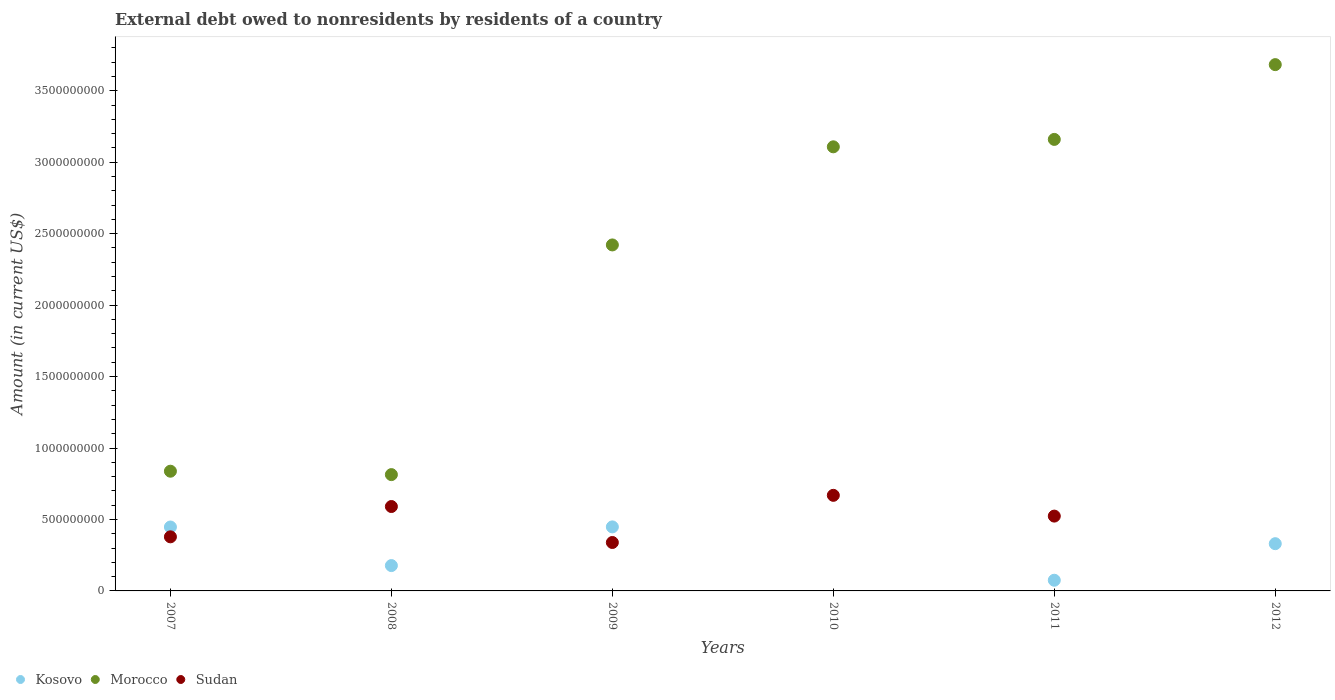Is the number of dotlines equal to the number of legend labels?
Keep it short and to the point. No. What is the external debt owed by residents in Kosovo in 2011?
Keep it short and to the point. 7.47e+07. Across all years, what is the maximum external debt owed by residents in Sudan?
Provide a succinct answer. 6.69e+08. Across all years, what is the minimum external debt owed by residents in Morocco?
Ensure brevity in your answer.  8.14e+08. In which year was the external debt owed by residents in Morocco maximum?
Provide a succinct answer. 2012. What is the total external debt owed by residents in Sudan in the graph?
Your response must be concise. 2.50e+09. What is the difference between the external debt owed by residents in Morocco in 2007 and that in 2009?
Give a very brief answer. -1.58e+09. What is the difference between the external debt owed by residents in Sudan in 2012 and the external debt owed by residents in Morocco in 2007?
Provide a short and direct response. -8.38e+08. What is the average external debt owed by residents in Morocco per year?
Ensure brevity in your answer.  2.34e+09. In the year 2012, what is the difference between the external debt owed by residents in Morocco and external debt owed by residents in Kosovo?
Your response must be concise. 3.35e+09. What is the ratio of the external debt owed by residents in Kosovo in 2009 to that in 2012?
Offer a very short reply. 1.36. What is the difference between the highest and the second highest external debt owed by residents in Sudan?
Give a very brief answer. 7.83e+07. What is the difference between the highest and the lowest external debt owed by residents in Morocco?
Make the answer very short. 2.87e+09. In how many years, is the external debt owed by residents in Morocco greater than the average external debt owed by residents in Morocco taken over all years?
Ensure brevity in your answer.  4. Is the external debt owed by residents in Kosovo strictly less than the external debt owed by residents in Morocco over the years?
Provide a short and direct response. Yes. How many years are there in the graph?
Provide a short and direct response. 6. Are the values on the major ticks of Y-axis written in scientific E-notation?
Offer a terse response. No. Where does the legend appear in the graph?
Your answer should be compact. Bottom left. What is the title of the graph?
Give a very brief answer. External debt owed to nonresidents by residents of a country. What is the label or title of the X-axis?
Keep it short and to the point. Years. What is the Amount (in current US$) in Kosovo in 2007?
Make the answer very short. 4.47e+08. What is the Amount (in current US$) in Morocco in 2007?
Your answer should be compact. 8.38e+08. What is the Amount (in current US$) in Sudan in 2007?
Your answer should be very brief. 3.79e+08. What is the Amount (in current US$) of Kosovo in 2008?
Your answer should be compact. 1.77e+08. What is the Amount (in current US$) in Morocco in 2008?
Provide a succinct answer. 8.14e+08. What is the Amount (in current US$) of Sudan in 2008?
Your answer should be compact. 5.91e+08. What is the Amount (in current US$) in Kosovo in 2009?
Make the answer very short. 4.48e+08. What is the Amount (in current US$) in Morocco in 2009?
Give a very brief answer. 2.42e+09. What is the Amount (in current US$) in Sudan in 2009?
Offer a very short reply. 3.39e+08. What is the Amount (in current US$) of Kosovo in 2010?
Your response must be concise. 0. What is the Amount (in current US$) in Morocco in 2010?
Make the answer very short. 3.11e+09. What is the Amount (in current US$) in Sudan in 2010?
Provide a succinct answer. 6.69e+08. What is the Amount (in current US$) in Kosovo in 2011?
Ensure brevity in your answer.  7.47e+07. What is the Amount (in current US$) in Morocco in 2011?
Provide a succinct answer. 3.16e+09. What is the Amount (in current US$) in Sudan in 2011?
Your response must be concise. 5.24e+08. What is the Amount (in current US$) of Kosovo in 2012?
Keep it short and to the point. 3.31e+08. What is the Amount (in current US$) of Morocco in 2012?
Your response must be concise. 3.68e+09. What is the Amount (in current US$) of Sudan in 2012?
Offer a terse response. 0. Across all years, what is the maximum Amount (in current US$) in Kosovo?
Offer a very short reply. 4.48e+08. Across all years, what is the maximum Amount (in current US$) in Morocco?
Offer a terse response. 3.68e+09. Across all years, what is the maximum Amount (in current US$) of Sudan?
Offer a very short reply. 6.69e+08. Across all years, what is the minimum Amount (in current US$) in Kosovo?
Ensure brevity in your answer.  0. Across all years, what is the minimum Amount (in current US$) of Morocco?
Your answer should be very brief. 8.14e+08. What is the total Amount (in current US$) of Kosovo in the graph?
Ensure brevity in your answer.  1.48e+09. What is the total Amount (in current US$) of Morocco in the graph?
Ensure brevity in your answer.  1.40e+1. What is the total Amount (in current US$) in Sudan in the graph?
Give a very brief answer. 2.50e+09. What is the difference between the Amount (in current US$) of Kosovo in 2007 and that in 2008?
Make the answer very short. 2.70e+08. What is the difference between the Amount (in current US$) of Morocco in 2007 and that in 2008?
Provide a succinct answer. 2.39e+07. What is the difference between the Amount (in current US$) in Sudan in 2007 and that in 2008?
Offer a terse response. -2.12e+08. What is the difference between the Amount (in current US$) of Kosovo in 2007 and that in 2009?
Make the answer very short. -8.17e+05. What is the difference between the Amount (in current US$) in Morocco in 2007 and that in 2009?
Provide a succinct answer. -1.58e+09. What is the difference between the Amount (in current US$) in Sudan in 2007 and that in 2009?
Give a very brief answer. 3.96e+07. What is the difference between the Amount (in current US$) in Morocco in 2007 and that in 2010?
Ensure brevity in your answer.  -2.27e+09. What is the difference between the Amount (in current US$) in Sudan in 2007 and that in 2010?
Your answer should be compact. -2.90e+08. What is the difference between the Amount (in current US$) in Kosovo in 2007 and that in 2011?
Offer a terse response. 3.73e+08. What is the difference between the Amount (in current US$) of Morocco in 2007 and that in 2011?
Give a very brief answer. -2.32e+09. What is the difference between the Amount (in current US$) of Sudan in 2007 and that in 2011?
Provide a short and direct response. -1.45e+08. What is the difference between the Amount (in current US$) in Kosovo in 2007 and that in 2012?
Your answer should be compact. 1.17e+08. What is the difference between the Amount (in current US$) of Morocco in 2007 and that in 2012?
Offer a terse response. -2.85e+09. What is the difference between the Amount (in current US$) in Kosovo in 2008 and that in 2009?
Provide a succinct answer. -2.71e+08. What is the difference between the Amount (in current US$) in Morocco in 2008 and that in 2009?
Keep it short and to the point. -1.61e+09. What is the difference between the Amount (in current US$) of Sudan in 2008 and that in 2009?
Keep it short and to the point. 2.52e+08. What is the difference between the Amount (in current US$) in Morocco in 2008 and that in 2010?
Provide a succinct answer. -2.29e+09. What is the difference between the Amount (in current US$) of Sudan in 2008 and that in 2010?
Your answer should be compact. -7.83e+07. What is the difference between the Amount (in current US$) of Kosovo in 2008 and that in 2011?
Keep it short and to the point. 1.03e+08. What is the difference between the Amount (in current US$) in Morocco in 2008 and that in 2011?
Make the answer very short. -2.35e+09. What is the difference between the Amount (in current US$) of Sudan in 2008 and that in 2011?
Your answer should be very brief. 6.70e+07. What is the difference between the Amount (in current US$) in Kosovo in 2008 and that in 2012?
Ensure brevity in your answer.  -1.53e+08. What is the difference between the Amount (in current US$) of Morocco in 2008 and that in 2012?
Ensure brevity in your answer.  -2.87e+09. What is the difference between the Amount (in current US$) in Morocco in 2009 and that in 2010?
Keep it short and to the point. -6.87e+08. What is the difference between the Amount (in current US$) of Sudan in 2009 and that in 2010?
Give a very brief answer. -3.30e+08. What is the difference between the Amount (in current US$) in Kosovo in 2009 and that in 2011?
Provide a succinct answer. 3.73e+08. What is the difference between the Amount (in current US$) of Morocco in 2009 and that in 2011?
Make the answer very short. -7.39e+08. What is the difference between the Amount (in current US$) in Sudan in 2009 and that in 2011?
Make the answer very short. -1.85e+08. What is the difference between the Amount (in current US$) in Kosovo in 2009 and that in 2012?
Ensure brevity in your answer.  1.18e+08. What is the difference between the Amount (in current US$) of Morocco in 2009 and that in 2012?
Ensure brevity in your answer.  -1.26e+09. What is the difference between the Amount (in current US$) of Morocco in 2010 and that in 2011?
Offer a terse response. -5.19e+07. What is the difference between the Amount (in current US$) in Sudan in 2010 and that in 2011?
Provide a succinct answer. 1.45e+08. What is the difference between the Amount (in current US$) of Morocco in 2010 and that in 2012?
Give a very brief answer. -5.75e+08. What is the difference between the Amount (in current US$) of Kosovo in 2011 and that in 2012?
Provide a succinct answer. -2.56e+08. What is the difference between the Amount (in current US$) in Morocco in 2011 and that in 2012?
Your answer should be compact. -5.23e+08. What is the difference between the Amount (in current US$) in Kosovo in 2007 and the Amount (in current US$) in Morocco in 2008?
Make the answer very short. -3.67e+08. What is the difference between the Amount (in current US$) of Kosovo in 2007 and the Amount (in current US$) of Sudan in 2008?
Make the answer very short. -1.43e+08. What is the difference between the Amount (in current US$) of Morocco in 2007 and the Amount (in current US$) of Sudan in 2008?
Give a very brief answer. 2.47e+08. What is the difference between the Amount (in current US$) in Kosovo in 2007 and the Amount (in current US$) in Morocco in 2009?
Offer a terse response. -1.97e+09. What is the difference between the Amount (in current US$) of Kosovo in 2007 and the Amount (in current US$) of Sudan in 2009?
Your answer should be compact. 1.08e+08. What is the difference between the Amount (in current US$) of Morocco in 2007 and the Amount (in current US$) of Sudan in 2009?
Offer a terse response. 4.99e+08. What is the difference between the Amount (in current US$) in Kosovo in 2007 and the Amount (in current US$) in Morocco in 2010?
Your response must be concise. -2.66e+09. What is the difference between the Amount (in current US$) of Kosovo in 2007 and the Amount (in current US$) of Sudan in 2010?
Provide a succinct answer. -2.22e+08. What is the difference between the Amount (in current US$) of Morocco in 2007 and the Amount (in current US$) of Sudan in 2010?
Your answer should be compact. 1.69e+08. What is the difference between the Amount (in current US$) of Kosovo in 2007 and the Amount (in current US$) of Morocco in 2011?
Make the answer very short. -2.71e+09. What is the difference between the Amount (in current US$) in Kosovo in 2007 and the Amount (in current US$) in Sudan in 2011?
Provide a short and direct response. -7.64e+07. What is the difference between the Amount (in current US$) in Morocco in 2007 and the Amount (in current US$) in Sudan in 2011?
Your answer should be very brief. 3.14e+08. What is the difference between the Amount (in current US$) in Kosovo in 2007 and the Amount (in current US$) in Morocco in 2012?
Provide a succinct answer. -3.24e+09. What is the difference between the Amount (in current US$) of Kosovo in 2008 and the Amount (in current US$) of Morocco in 2009?
Offer a very short reply. -2.24e+09. What is the difference between the Amount (in current US$) of Kosovo in 2008 and the Amount (in current US$) of Sudan in 2009?
Offer a terse response. -1.62e+08. What is the difference between the Amount (in current US$) in Morocco in 2008 and the Amount (in current US$) in Sudan in 2009?
Offer a very short reply. 4.75e+08. What is the difference between the Amount (in current US$) of Kosovo in 2008 and the Amount (in current US$) of Morocco in 2010?
Make the answer very short. -2.93e+09. What is the difference between the Amount (in current US$) of Kosovo in 2008 and the Amount (in current US$) of Sudan in 2010?
Provide a succinct answer. -4.92e+08. What is the difference between the Amount (in current US$) of Morocco in 2008 and the Amount (in current US$) of Sudan in 2010?
Your response must be concise. 1.45e+08. What is the difference between the Amount (in current US$) of Kosovo in 2008 and the Amount (in current US$) of Morocco in 2011?
Make the answer very short. -2.98e+09. What is the difference between the Amount (in current US$) in Kosovo in 2008 and the Amount (in current US$) in Sudan in 2011?
Offer a very short reply. -3.46e+08. What is the difference between the Amount (in current US$) of Morocco in 2008 and the Amount (in current US$) of Sudan in 2011?
Give a very brief answer. 2.90e+08. What is the difference between the Amount (in current US$) of Kosovo in 2008 and the Amount (in current US$) of Morocco in 2012?
Provide a succinct answer. -3.51e+09. What is the difference between the Amount (in current US$) of Kosovo in 2009 and the Amount (in current US$) of Morocco in 2010?
Your answer should be compact. -2.66e+09. What is the difference between the Amount (in current US$) of Kosovo in 2009 and the Amount (in current US$) of Sudan in 2010?
Give a very brief answer. -2.21e+08. What is the difference between the Amount (in current US$) in Morocco in 2009 and the Amount (in current US$) in Sudan in 2010?
Your answer should be compact. 1.75e+09. What is the difference between the Amount (in current US$) of Kosovo in 2009 and the Amount (in current US$) of Morocco in 2011?
Your answer should be compact. -2.71e+09. What is the difference between the Amount (in current US$) in Kosovo in 2009 and the Amount (in current US$) in Sudan in 2011?
Your response must be concise. -7.55e+07. What is the difference between the Amount (in current US$) of Morocco in 2009 and the Amount (in current US$) of Sudan in 2011?
Ensure brevity in your answer.  1.90e+09. What is the difference between the Amount (in current US$) of Kosovo in 2009 and the Amount (in current US$) of Morocco in 2012?
Provide a succinct answer. -3.23e+09. What is the difference between the Amount (in current US$) of Morocco in 2010 and the Amount (in current US$) of Sudan in 2011?
Offer a very short reply. 2.58e+09. What is the difference between the Amount (in current US$) of Kosovo in 2011 and the Amount (in current US$) of Morocco in 2012?
Provide a succinct answer. -3.61e+09. What is the average Amount (in current US$) in Kosovo per year?
Make the answer very short. 2.46e+08. What is the average Amount (in current US$) of Morocco per year?
Offer a terse response. 2.34e+09. What is the average Amount (in current US$) in Sudan per year?
Your answer should be compact. 4.17e+08. In the year 2007, what is the difference between the Amount (in current US$) in Kosovo and Amount (in current US$) in Morocco?
Provide a succinct answer. -3.91e+08. In the year 2007, what is the difference between the Amount (in current US$) in Kosovo and Amount (in current US$) in Sudan?
Give a very brief answer. 6.87e+07. In the year 2007, what is the difference between the Amount (in current US$) in Morocco and Amount (in current US$) in Sudan?
Your answer should be very brief. 4.59e+08. In the year 2008, what is the difference between the Amount (in current US$) of Kosovo and Amount (in current US$) of Morocco?
Your answer should be very brief. -6.37e+08. In the year 2008, what is the difference between the Amount (in current US$) of Kosovo and Amount (in current US$) of Sudan?
Provide a short and direct response. -4.13e+08. In the year 2008, what is the difference between the Amount (in current US$) of Morocco and Amount (in current US$) of Sudan?
Keep it short and to the point. 2.23e+08. In the year 2009, what is the difference between the Amount (in current US$) of Kosovo and Amount (in current US$) of Morocco?
Ensure brevity in your answer.  -1.97e+09. In the year 2009, what is the difference between the Amount (in current US$) in Kosovo and Amount (in current US$) in Sudan?
Ensure brevity in your answer.  1.09e+08. In the year 2009, what is the difference between the Amount (in current US$) in Morocco and Amount (in current US$) in Sudan?
Your answer should be very brief. 2.08e+09. In the year 2010, what is the difference between the Amount (in current US$) in Morocco and Amount (in current US$) in Sudan?
Offer a very short reply. 2.44e+09. In the year 2011, what is the difference between the Amount (in current US$) of Kosovo and Amount (in current US$) of Morocco?
Keep it short and to the point. -3.09e+09. In the year 2011, what is the difference between the Amount (in current US$) of Kosovo and Amount (in current US$) of Sudan?
Give a very brief answer. -4.49e+08. In the year 2011, what is the difference between the Amount (in current US$) in Morocco and Amount (in current US$) in Sudan?
Your response must be concise. 2.64e+09. In the year 2012, what is the difference between the Amount (in current US$) of Kosovo and Amount (in current US$) of Morocco?
Ensure brevity in your answer.  -3.35e+09. What is the ratio of the Amount (in current US$) of Kosovo in 2007 to that in 2008?
Provide a succinct answer. 2.52. What is the ratio of the Amount (in current US$) in Morocco in 2007 to that in 2008?
Your response must be concise. 1.03. What is the ratio of the Amount (in current US$) in Sudan in 2007 to that in 2008?
Keep it short and to the point. 0.64. What is the ratio of the Amount (in current US$) of Morocco in 2007 to that in 2009?
Your answer should be very brief. 0.35. What is the ratio of the Amount (in current US$) of Sudan in 2007 to that in 2009?
Offer a terse response. 1.12. What is the ratio of the Amount (in current US$) of Morocco in 2007 to that in 2010?
Keep it short and to the point. 0.27. What is the ratio of the Amount (in current US$) in Sudan in 2007 to that in 2010?
Give a very brief answer. 0.57. What is the ratio of the Amount (in current US$) of Kosovo in 2007 to that in 2011?
Give a very brief answer. 5.98. What is the ratio of the Amount (in current US$) in Morocco in 2007 to that in 2011?
Keep it short and to the point. 0.27. What is the ratio of the Amount (in current US$) in Sudan in 2007 to that in 2011?
Provide a short and direct response. 0.72. What is the ratio of the Amount (in current US$) of Kosovo in 2007 to that in 2012?
Provide a succinct answer. 1.35. What is the ratio of the Amount (in current US$) in Morocco in 2007 to that in 2012?
Provide a succinct answer. 0.23. What is the ratio of the Amount (in current US$) of Kosovo in 2008 to that in 2009?
Keep it short and to the point. 0.4. What is the ratio of the Amount (in current US$) of Morocco in 2008 to that in 2009?
Offer a very short reply. 0.34. What is the ratio of the Amount (in current US$) of Sudan in 2008 to that in 2009?
Your answer should be very brief. 1.74. What is the ratio of the Amount (in current US$) of Morocco in 2008 to that in 2010?
Make the answer very short. 0.26. What is the ratio of the Amount (in current US$) in Sudan in 2008 to that in 2010?
Make the answer very short. 0.88. What is the ratio of the Amount (in current US$) in Kosovo in 2008 to that in 2011?
Give a very brief answer. 2.37. What is the ratio of the Amount (in current US$) of Morocco in 2008 to that in 2011?
Give a very brief answer. 0.26. What is the ratio of the Amount (in current US$) in Sudan in 2008 to that in 2011?
Provide a succinct answer. 1.13. What is the ratio of the Amount (in current US$) in Kosovo in 2008 to that in 2012?
Offer a terse response. 0.54. What is the ratio of the Amount (in current US$) in Morocco in 2008 to that in 2012?
Provide a short and direct response. 0.22. What is the ratio of the Amount (in current US$) of Morocco in 2009 to that in 2010?
Offer a terse response. 0.78. What is the ratio of the Amount (in current US$) of Sudan in 2009 to that in 2010?
Ensure brevity in your answer.  0.51. What is the ratio of the Amount (in current US$) of Kosovo in 2009 to that in 2011?
Provide a succinct answer. 6. What is the ratio of the Amount (in current US$) in Morocco in 2009 to that in 2011?
Provide a short and direct response. 0.77. What is the ratio of the Amount (in current US$) in Sudan in 2009 to that in 2011?
Give a very brief answer. 0.65. What is the ratio of the Amount (in current US$) in Kosovo in 2009 to that in 2012?
Your response must be concise. 1.36. What is the ratio of the Amount (in current US$) in Morocco in 2009 to that in 2012?
Give a very brief answer. 0.66. What is the ratio of the Amount (in current US$) in Morocco in 2010 to that in 2011?
Ensure brevity in your answer.  0.98. What is the ratio of the Amount (in current US$) of Sudan in 2010 to that in 2011?
Your response must be concise. 1.28. What is the ratio of the Amount (in current US$) of Morocco in 2010 to that in 2012?
Provide a succinct answer. 0.84. What is the ratio of the Amount (in current US$) of Kosovo in 2011 to that in 2012?
Offer a terse response. 0.23. What is the ratio of the Amount (in current US$) of Morocco in 2011 to that in 2012?
Ensure brevity in your answer.  0.86. What is the difference between the highest and the second highest Amount (in current US$) in Kosovo?
Offer a terse response. 8.17e+05. What is the difference between the highest and the second highest Amount (in current US$) in Morocco?
Provide a succinct answer. 5.23e+08. What is the difference between the highest and the second highest Amount (in current US$) of Sudan?
Keep it short and to the point. 7.83e+07. What is the difference between the highest and the lowest Amount (in current US$) in Kosovo?
Ensure brevity in your answer.  4.48e+08. What is the difference between the highest and the lowest Amount (in current US$) in Morocco?
Provide a short and direct response. 2.87e+09. What is the difference between the highest and the lowest Amount (in current US$) in Sudan?
Your response must be concise. 6.69e+08. 